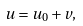Convert formula to latex. <formula><loc_0><loc_0><loc_500><loc_500>u = u _ { 0 } + v ,</formula> 